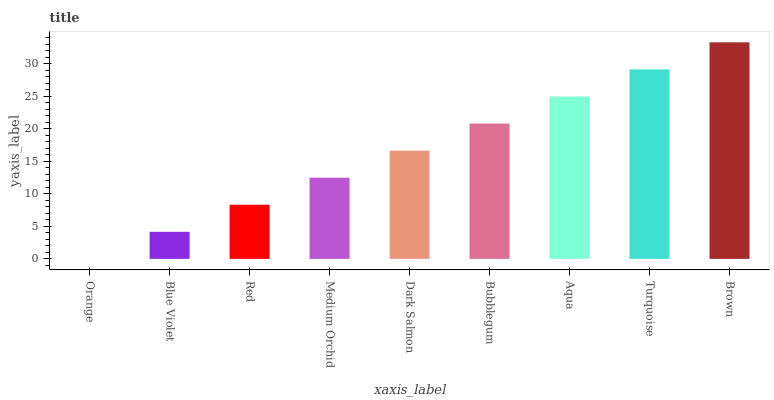Is Orange the minimum?
Answer yes or no. Yes. Is Brown the maximum?
Answer yes or no. Yes. Is Blue Violet the minimum?
Answer yes or no. No. Is Blue Violet the maximum?
Answer yes or no. No. Is Blue Violet greater than Orange?
Answer yes or no. Yes. Is Orange less than Blue Violet?
Answer yes or no. Yes. Is Orange greater than Blue Violet?
Answer yes or no. No. Is Blue Violet less than Orange?
Answer yes or no. No. Is Dark Salmon the high median?
Answer yes or no. Yes. Is Dark Salmon the low median?
Answer yes or no. Yes. Is Aqua the high median?
Answer yes or no. No. Is Medium Orchid the low median?
Answer yes or no. No. 